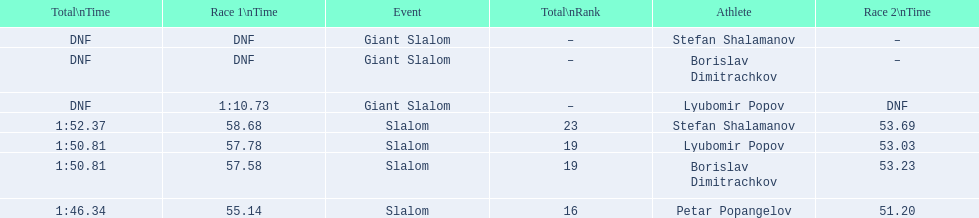What is the number of athletes to finish race one in the giant slalom? 1. 